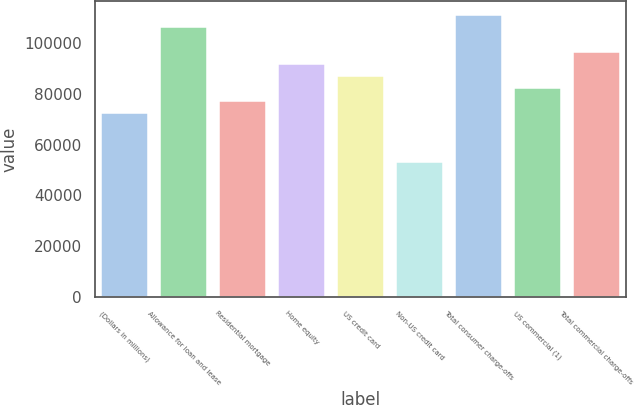Convert chart to OTSL. <chart><loc_0><loc_0><loc_500><loc_500><bar_chart><fcel>(Dollars in millions)<fcel>Allowance for loan and lease<fcel>Residential mortgage<fcel>Home equity<fcel>US credit card<fcel>Non-US credit card<fcel>Total consumer charge-offs<fcel>US commercial (1)<fcel>Total commercial charge-offs<nl><fcel>72538.5<fcel>106380<fcel>77373<fcel>91876.5<fcel>87042<fcel>53200.5<fcel>111214<fcel>82207.5<fcel>96711<nl></chart> 